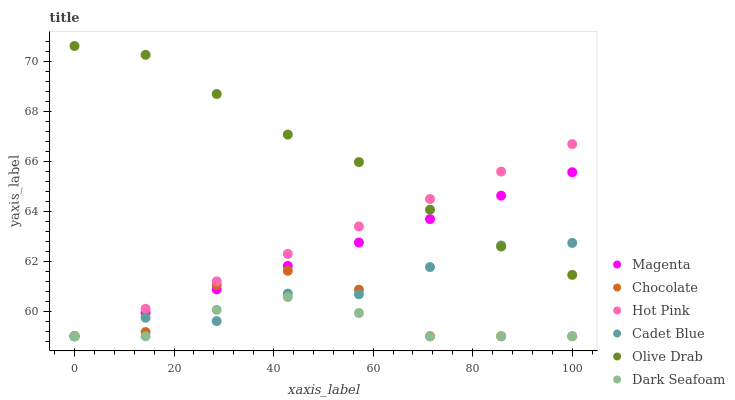Does Dark Seafoam have the minimum area under the curve?
Answer yes or no. Yes. Does Olive Drab have the maximum area under the curve?
Answer yes or no. Yes. Does Hot Pink have the minimum area under the curve?
Answer yes or no. No. Does Hot Pink have the maximum area under the curve?
Answer yes or no. No. Is Magenta the smoothest?
Answer yes or no. Yes. Is Chocolate the roughest?
Answer yes or no. Yes. Is Hot Pink the smoothest?
Answer yes or no. No. Is Hot Pink the roughest?
Answer yes or no. No. Does Cadet Blue have the lowest value?
Answer yes or no. Yes. Does Olive Drab have the lowest value?
Answer yes or no. No. Does Olive Drab have the highest value?
Answer yes or no. Yes. Does Hot Pink have the highest value?
Answer yes or no. No. Is Dark Seafoam less than Olive Drab?
Answer yes or no. Yes. Is Olive Drab greater than Chocolate?
Answer yes or no. Yes. Does Magenta intersect Cadet Blue?
Answer yes or no. Yes. Is Magenta less than Cadet Blue?
Answer yes or no. No. Is Magenta greater than Cadet Blue?
Answer yes or no. No. Does Dark Seafoam intersect Olive Drab?
Answer yes or no. No. 